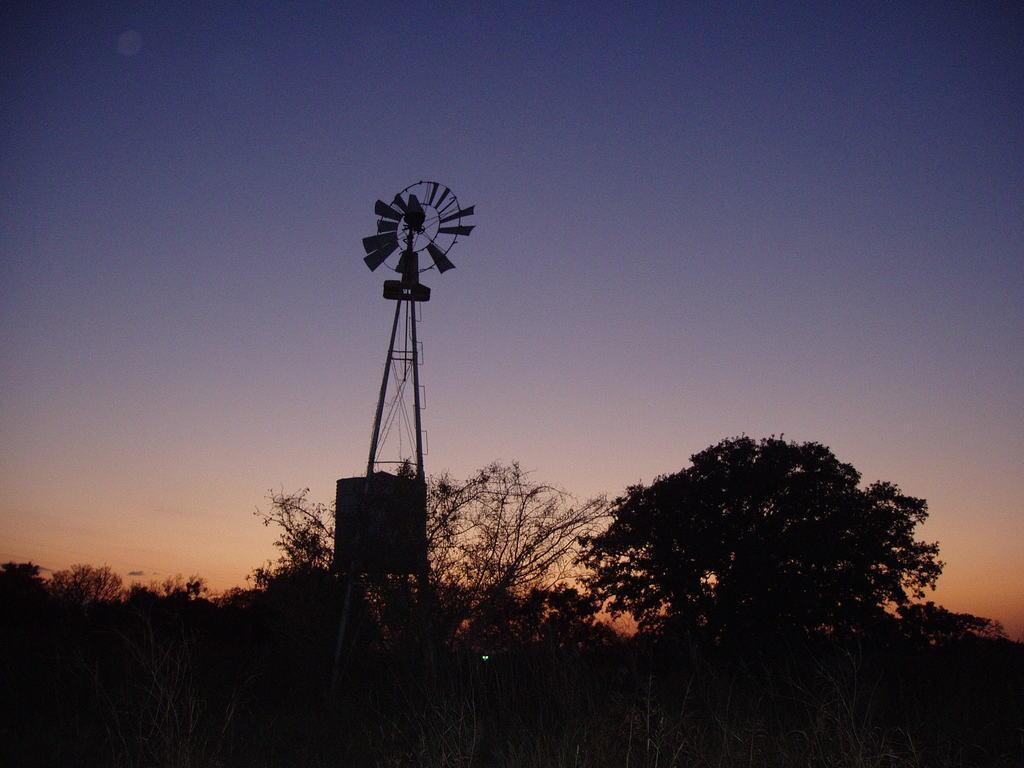Can you describe this image briefly? In this image we can see a windmill placed on the ground. In the background we can see group of trees and sky. 